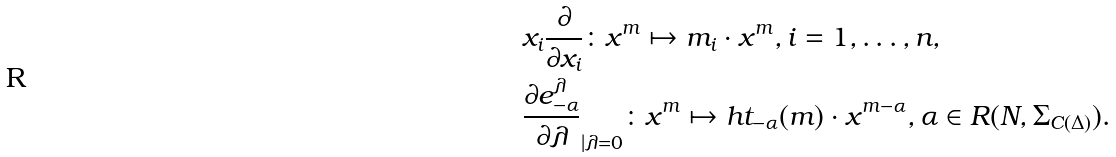Convert formula to latex. <formula><loc_0><loc_0><loc_500><loc_500>& x _ { i } \frac { \partial } { \partial x _ { i } } \colon x ^ { m } \mapsto m _ { i } \cdot x ^ { m } , i = 1 , \dots , n , \\ & \frac { \partial e _ { - \alpha } ^ { \lambda } } { \partial \lambda } _ { | { \lambda = 0 } } \colon x ^ { m } \mapsto h t _ { - \alpha } ( m ) \cdot x ^ { m - \alpha } , \alpha \in R ( N , \Sigma _ { C ( \Delta ) } ) .</formula> 